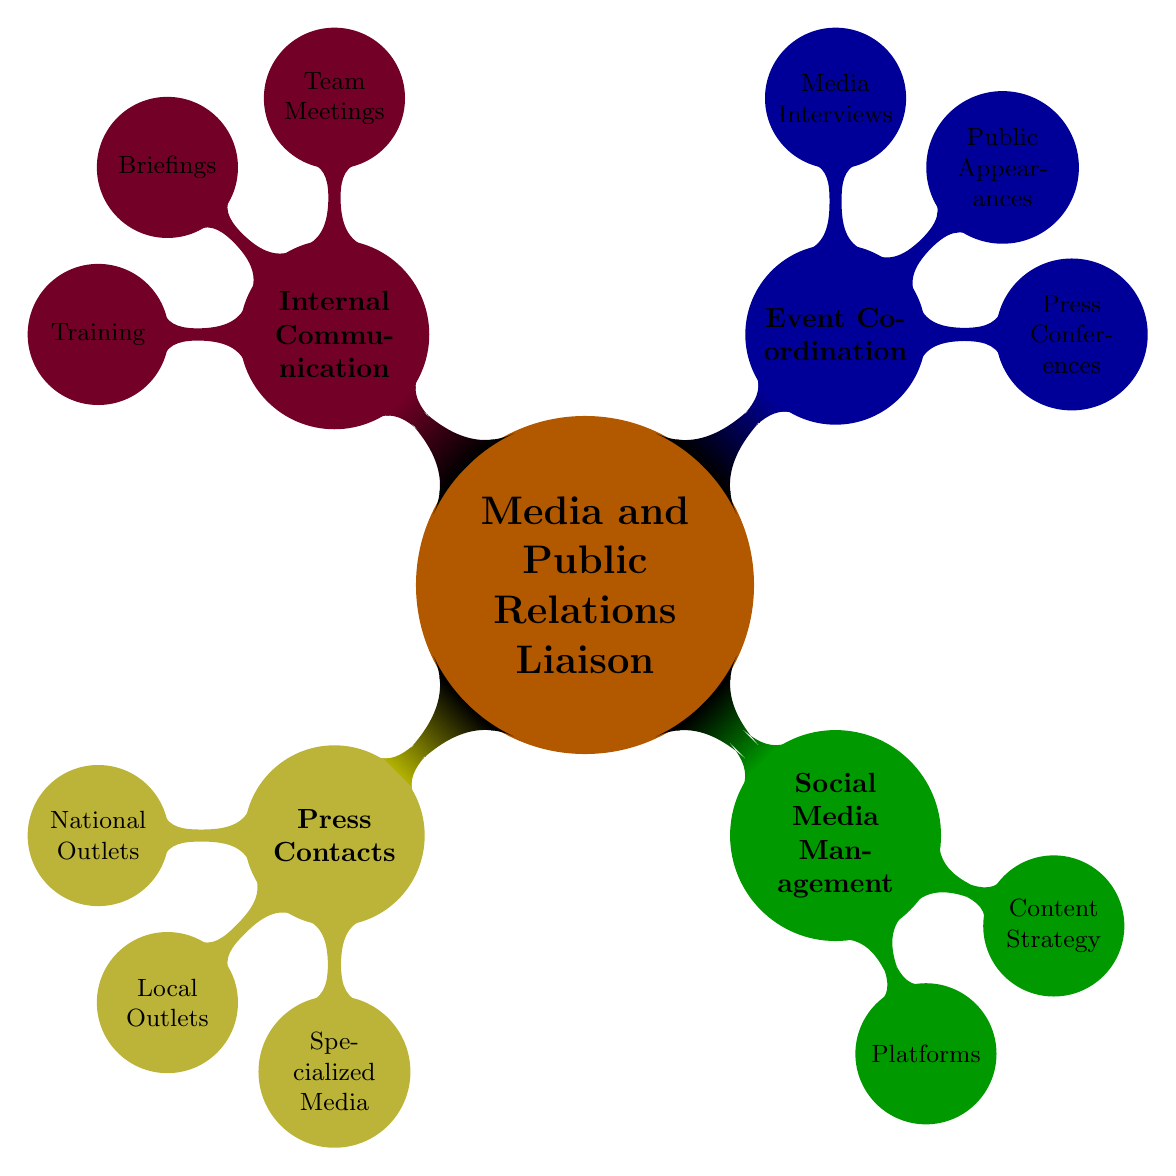What are three examples of National Outlets under Press Contacts? The diagram lists three National Outlets directly under the Press Contacts node: The New York Times, CNN, and BBC.
Answer: The New York Times, CNN, BBC How many nodes are under Social Media Management? The Social Media Management node has two child nodes: Platforms and Content Strategy, making a total of two nodes under it.
Answer: 2 Which type of events are included under Event Coordination? The Event Coordination node branches into three specific types: Press Conferences, Public Appearances, and Media Interviews. Hence, the types of events included are threefold.
Answer: Press Conferences, Public Appearances, Media Interviews What is included in Internal Communication under Briefings? The Briefings node encompasses two distinct aspects: Daily Briefings and Special Reports, indicating what type of content is prepared for internal communication.
Answer: Daily Briefings, Special Reports Which type of media is included under Specialized Media? The Specialized Media node lists three specific media types: Politico, The Hill, and NPR, indicating the variety of specialized outlets available for press contacts.
Answer: Politico, The Hill, NPR Count the total number of nodes in the Mind Map. The Mind Map consists of one root node (Media and Public Relations Liaison) and 11 child nodes (3 under Press Contacts, 2 under Social Media Management, 3 under Event Coordination, and 3 under Internal Communication). Therefore, the total number of nodes is 12.
Answer: 12 Which node details the training aspect in Internal Communication? The Training node is specifically mentioned under Internal Communication and highlights the focus on Media Training and Crisis Response Drills as essential components of training.
Answer: Training What strategy does Social Media Management include? The Content Strategy node includes Engagement Campaigns, Crisis Management, and Regular Updates as strategies to be employed under Social Media Management, indicating a proactive approach to handling social media.
Answer: Engagement Campaigns, Crisis Management, Regular Updates 